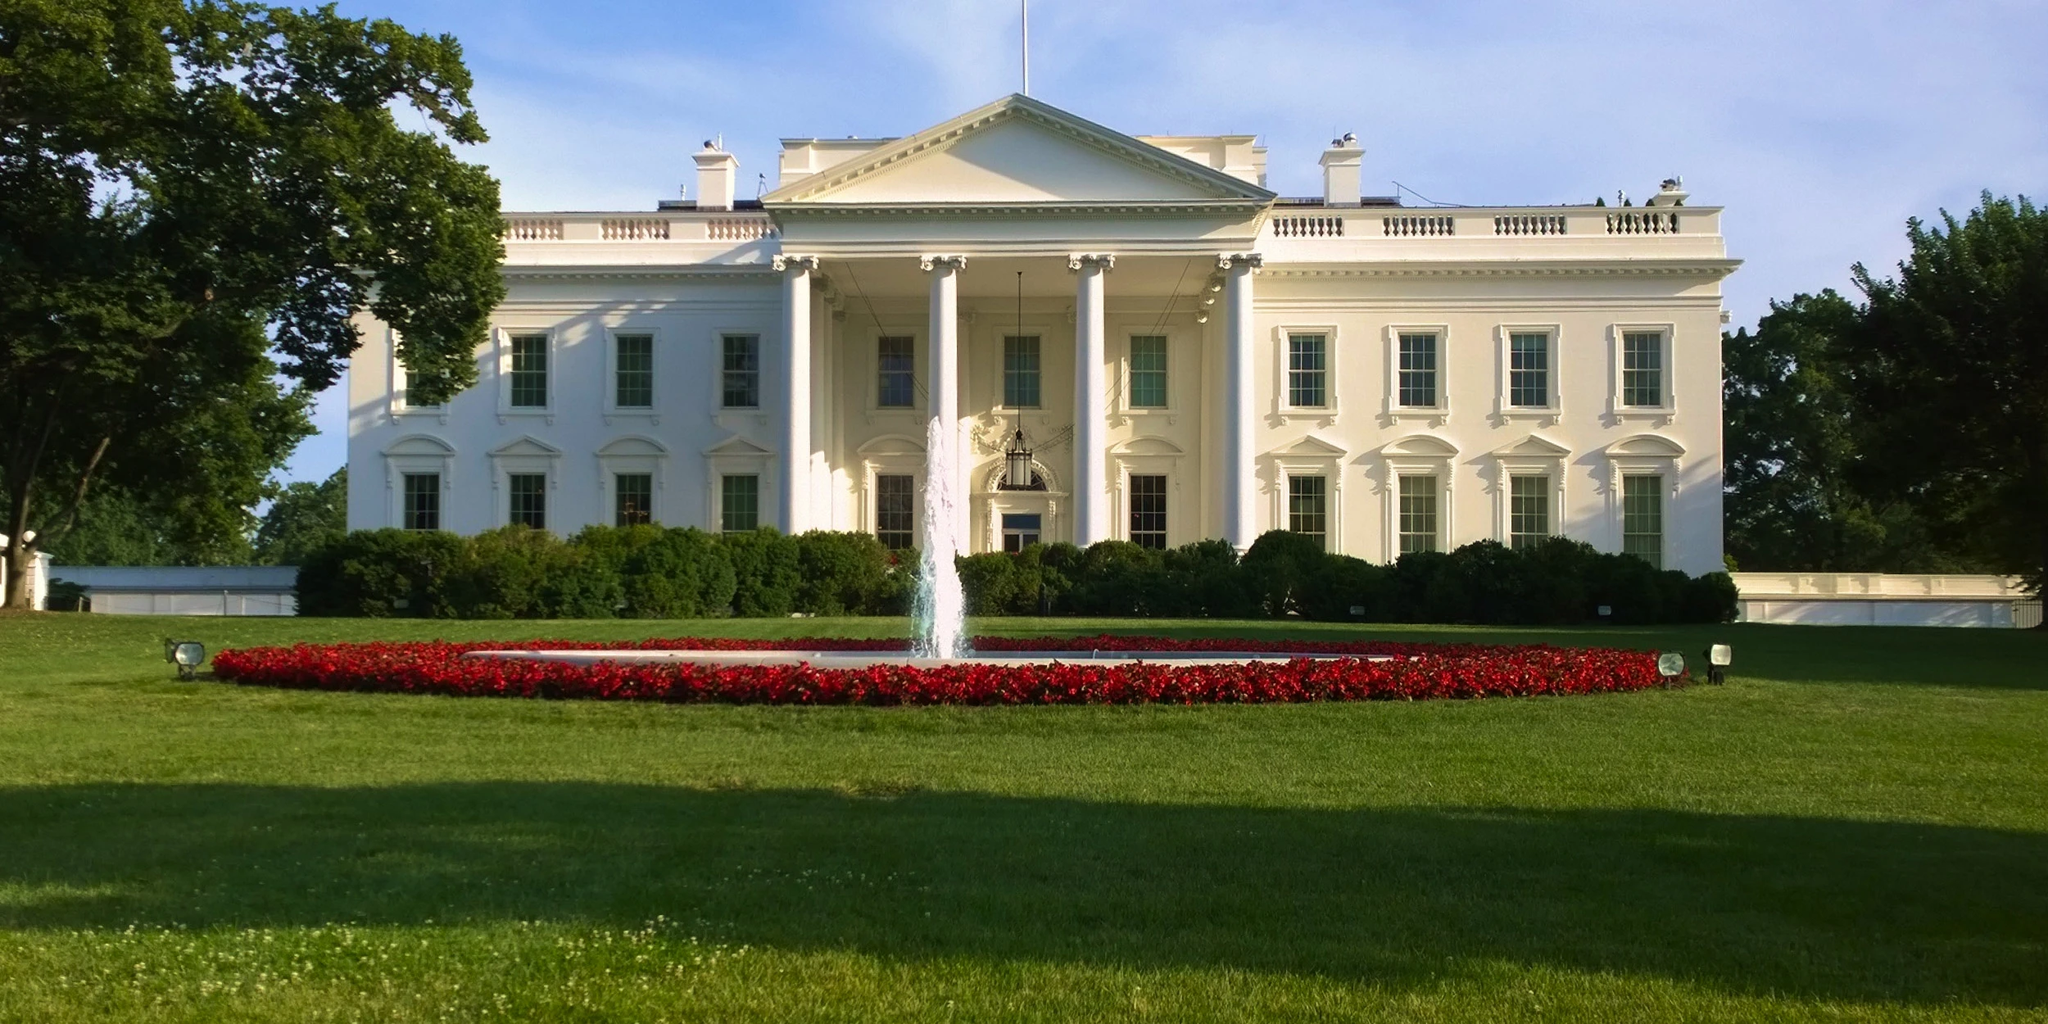What can you tell me about the architectural style of the White House? The White House is an excellent example of neoclassical architecture, a style that emerged in the mid-18th century. This architectural style draws inspiration from classical Greek and Roman architecture, emphasizing symmetry, grandeur, and the use of columns. The White House features a grand portico with towering columns on the north facade, which is characteristic of neoclassical design. This style was chosen to convey the ideals of democracy and the Republic, drawing a connection between the United States and the classical civilizations of Greece and Rome. 